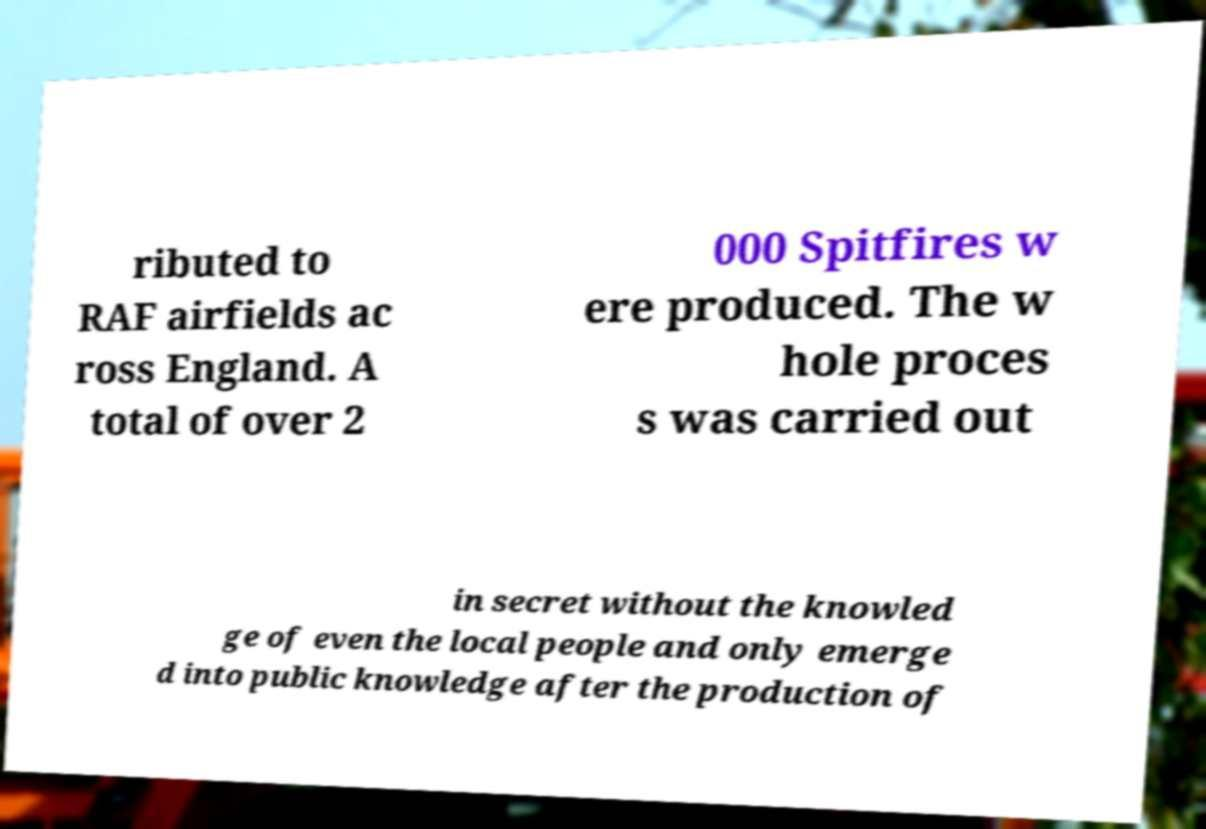Please read and relay the text visible in this image. What does it say? ributed to RAF airfields ac ross England. A total of over 2 000 Spitfires w ere produced. The w hole proces s was carried out in secret without the knowled ge of even the local people and only emerge d into public knowledge after the production of 